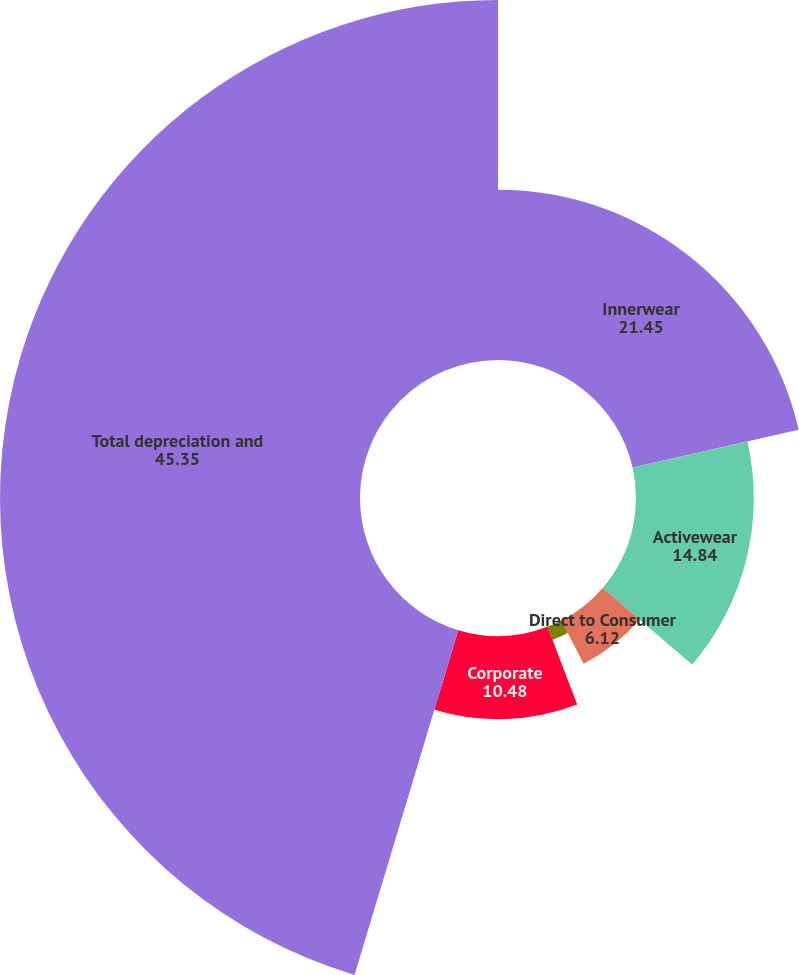<chart> <loc_0><loc_0><loc_500><loc_500><pie_chart><fcel>Innerwear<fcel>Activewear<fcel>Direct to Consumer<fcel>International<fcel>Corporate<fcel>Total depreciation and<nl><fcel>21.45%<fcel>14.84%<fcel>6.12%<fcel>1.76%<fcel>10.48%<fcel>45.35%<nl></chart> 